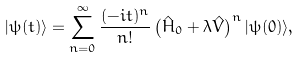<formula> <loc_0><loc_0><loc_500><loc_500>| \psi ( t ) \rangle = \sum _ { n = 0 } ^ { \infty } \frac { ( - i t ) ^ { n } } { n ! } \left ( \hat { H } _ { 0 } + \lambda \hat { V } \right ) ^ { n } | \psi ( 0 ) \rangle ,</formula> 